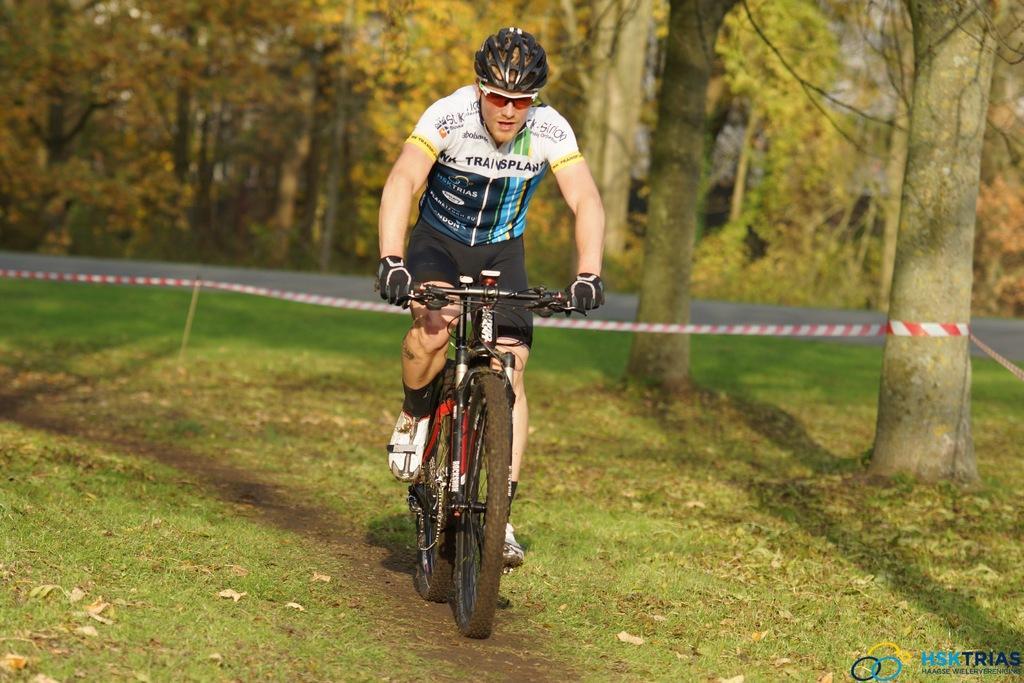Can you describe this image briefly? In this image I can see a man riding the bicycle. He's wearing a helmet on his head. It seems like a forest area. In the background I can see trees and road. 